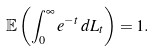Convert formula to latex. <formula><loc_0><loc_0><loc_500><loc_500>\mathbb { E } \left ( \int _ { 0 } ^ { \infty } e ^ { - t } \, d L _ { t } \right ) = 1 .</formula> 